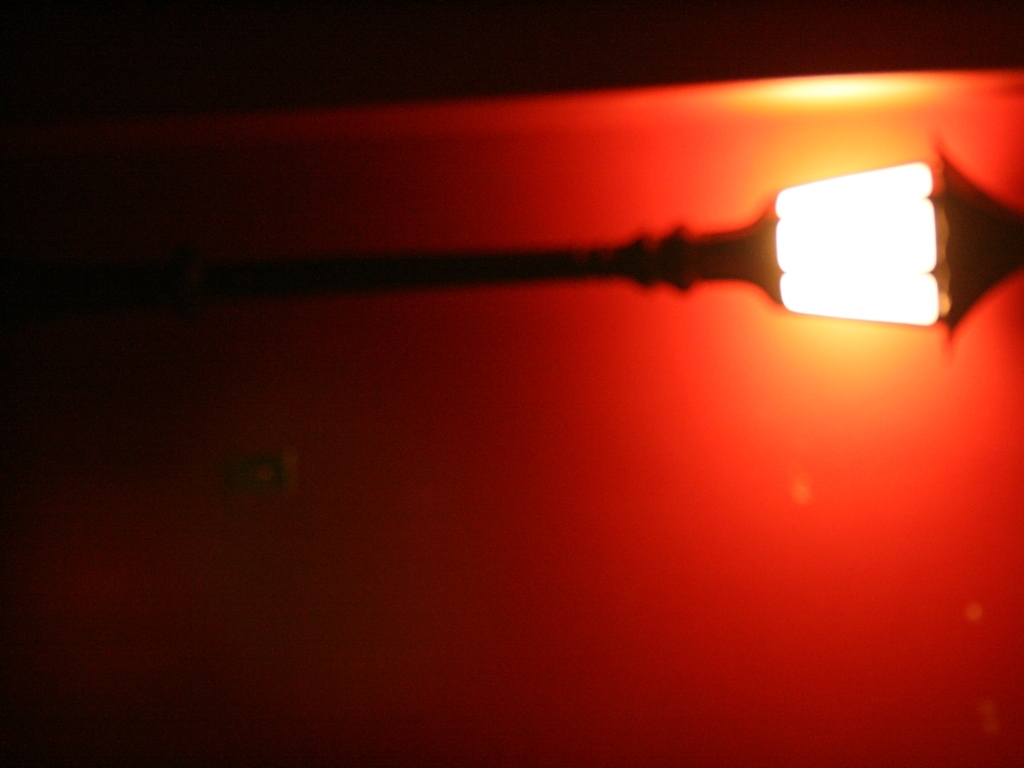What is the overall image clarity of this picture?
A. Average
B. Poor
C. Good
Answer with the option's letter from the given choices directly. The image clarity can be defined as poor due to noticeable blur and lack of sharpness, particularly around the edges of the illuminated object, which affects the details that can be discerned. 